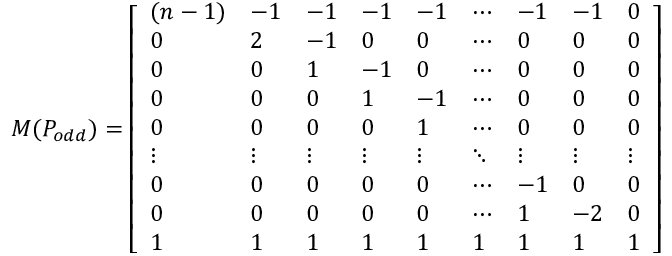<formula> <loc_0><loc_0><loc_500><loc_500>M ( P _ { o d d } ) = \left [ \begin{array} { l l l l l l l l l } { ( n - 1 ) } & { - 1 } & { - 1 } & { - 1 } & { - 1 } & { \cdots } & { - 1 } & { - 1 } & { 0 } \\ { 0 } & { 2 } & { - 1 } & { 0 } & { 0 } & { \cdots } & { 0 } & { 0 } & { 0 } \\ { 0 } & { 0 } & { 1 } & { - 1 } & { 0 } & { \cdots } & { 0 } & { 0 } & { 0 } \\ { 0 } & { 0 } & { 0 } & { 1 } & { - 1 } & { \cdots } & { 0 } & { 0 } & { 0 } \\ { 0 } & { 0 } & { 0 } & { 0 } & { 1 } & { \cdots } & { 0 } & { 0 } & { 0 } \\ { \vdots } & { \vdots } & { \vdots } & { \vdots } & { \vdots } & { \ddots } & { \vdots } & { \vdots } & { \vdots } \\ { 0 } & { 0 } & { 0 } & { 0 } & { 0 } & { \cdots } & { - 1 } & { 0 } & { 0 } \\ { 0 } & { 0 } & { 0 } & { 0 } & { 0 } & { \cdots } & { 1 } & { - 2 } & { 0 } \\ { 1 } & { 1 } & { 1 } & { 1 } & { 1 } & { 1 } & { 1 } & { 1 } & { 1 } \end{array} \right ]</formula> 